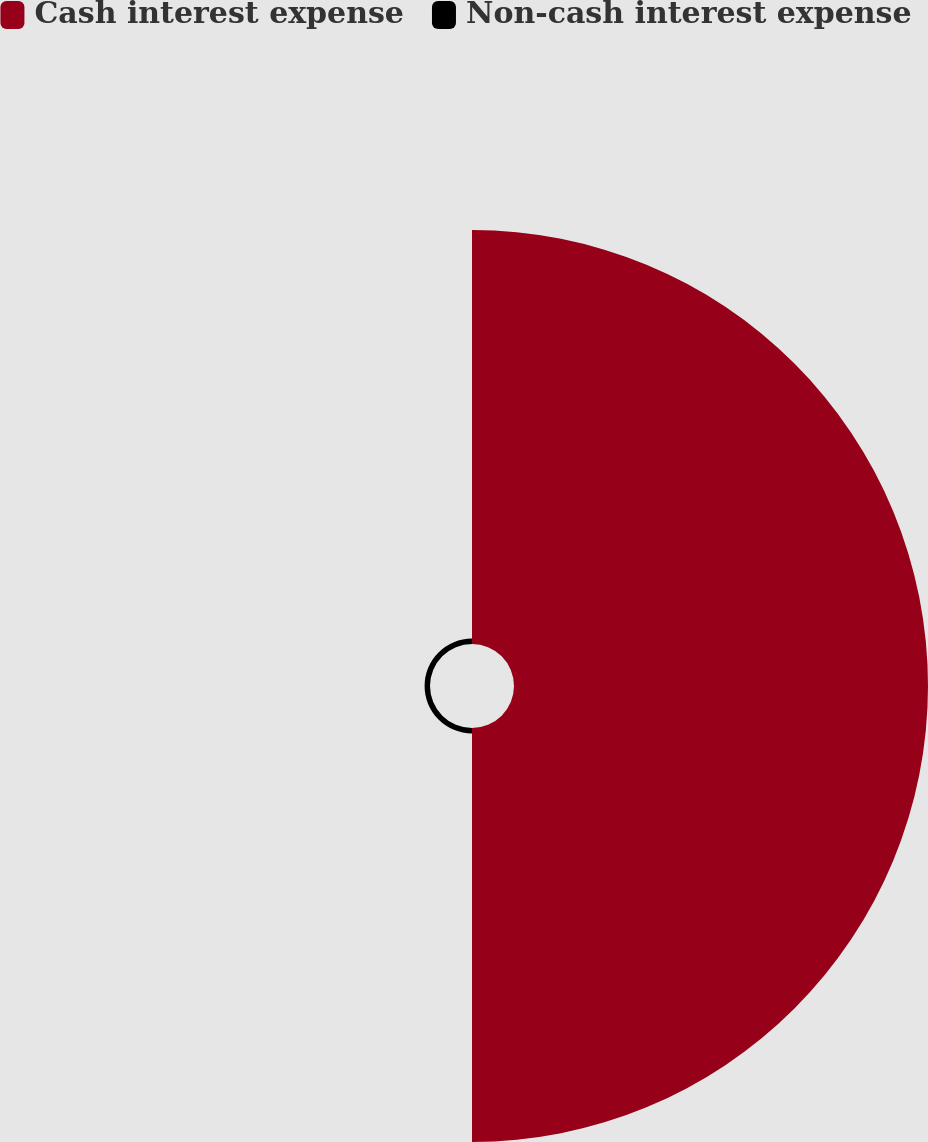Convert chart to OTSL. <chart><loc_0><loc_0><loc_500><loc_500><pie_chart><fcel>Cash interest expense<fcel>Non-cash interest expense<nl><fcel>98.71%<fcel>1.29%<nl></chart> 